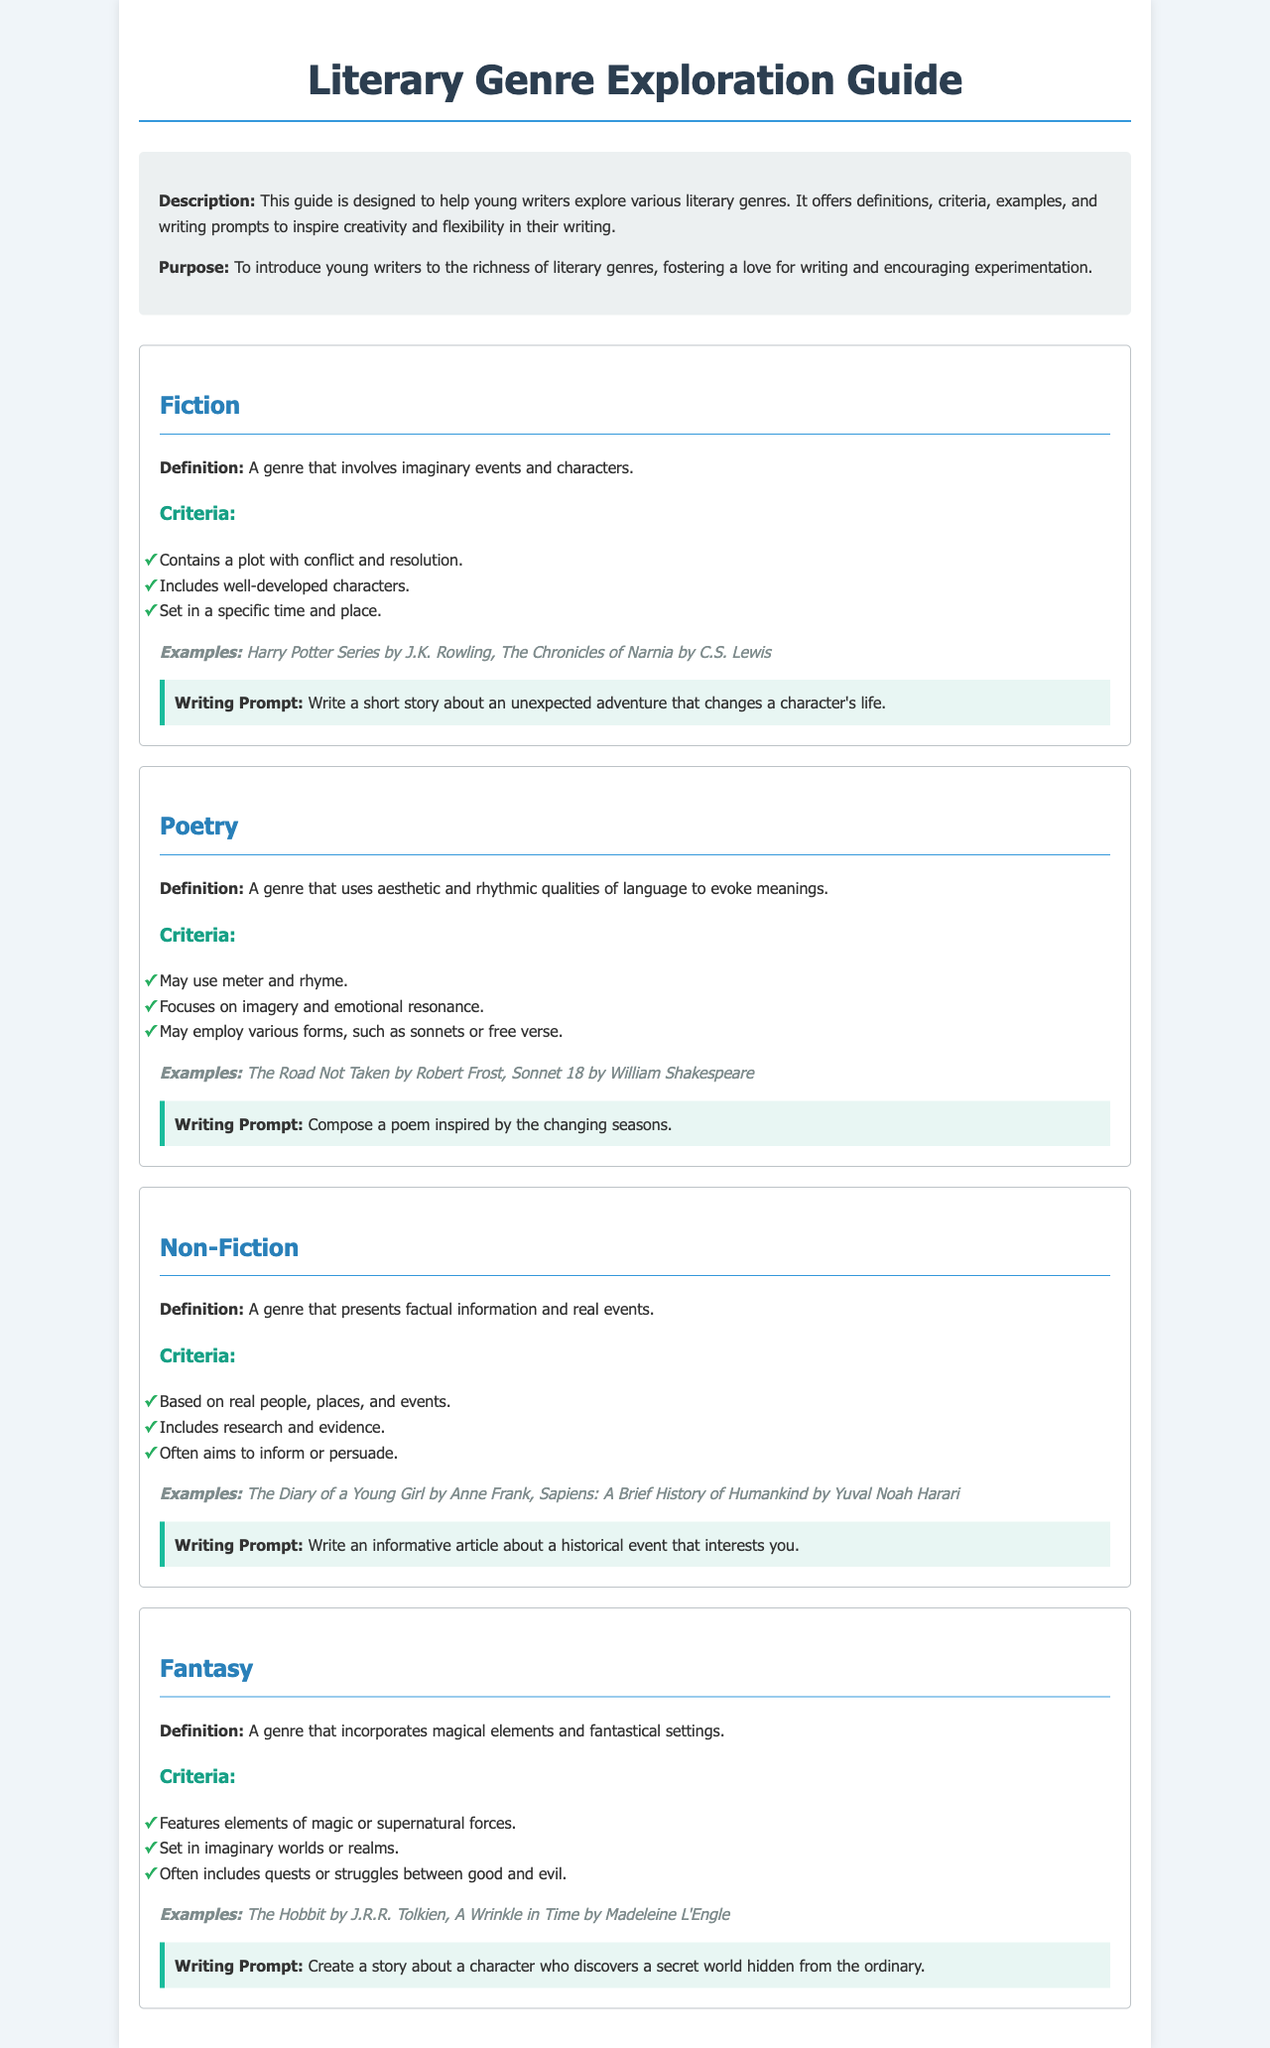What is the title of the guide? The title of the guide is the main heading displayed prominently at the top of the document.
Answer: Literary Genre Exploration Guide What genre is associated with imaginary events? This genre is defined in the document and includes criteria for storytelling.
Answer: Fiction Who wrote "The Road Not Taken"? The document provides an example of poetry and names its author.
Answer: Robert Frost What is one criterion for poetry? The criteria for poetry are listed within the section dedicated to this genre.
Answer: Focuses on imagery and emotional resonance What writing prompt is given for non-fiction? The writing prompt provided encourages young writers to create informative content.
Answer: Write an informative article about a historical event that interests you What characterizes the fantasy genre? The document outlines key elements that define this literary genre.
Answer: Features elements of magic or supernatural forces How many literary genres are introduced in the guide? The genres are explicitly listed in separate sections.
Answer: Four What is the purpose of the guide? The purpose is articulated in the introduction, describing its aim towards young writers.
Answer: To introduce young writers to the richness of literary genres 